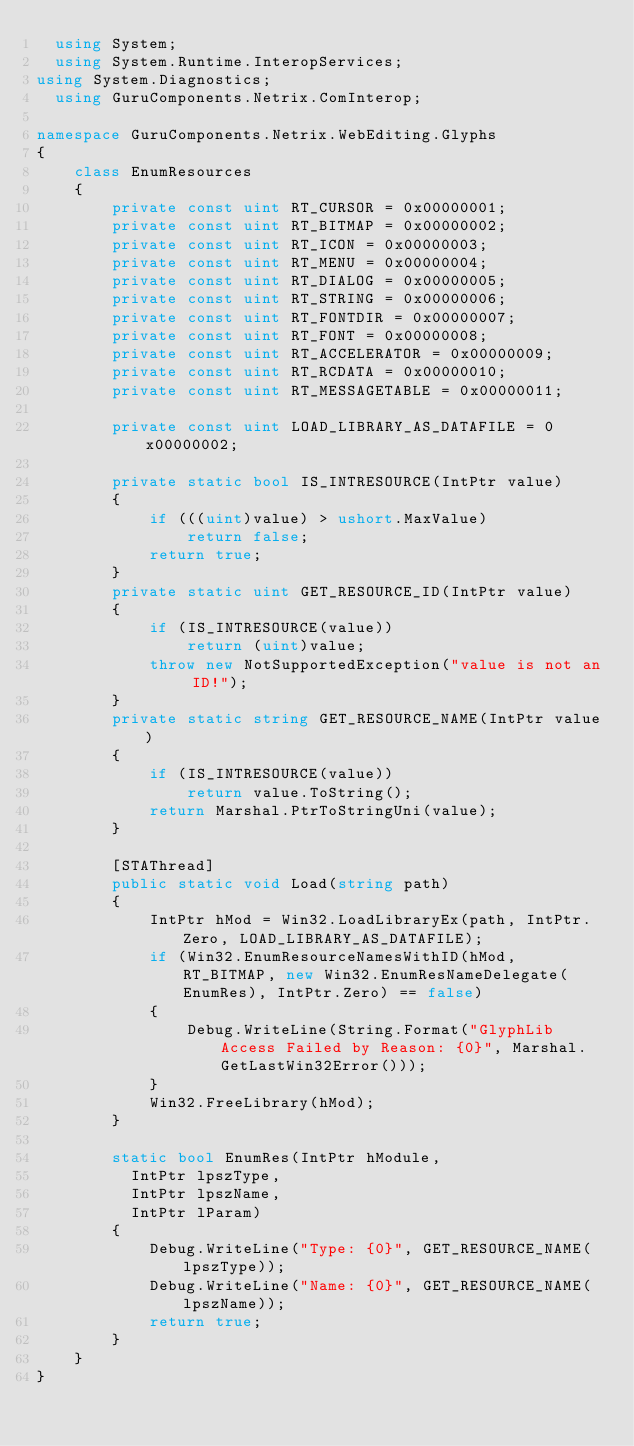Convert code to text. <code><loc_0><loc_0><loc_500><loc_500><_C#_>  using System;
  using System.Runtime.InteropServices;
using System.Diagnostics;
  using GuruComponents.Netrix.ComInterop;

namespace GuruComponents.Netrix.WebEditing.Glyphs
{
    class EnumResources
    {
        private const uint RT_CURSOR = 0x00000001;
        private const uint RT_BITMAP = 0x00000002;
        private const uint RT_ICON = 0x00000003;
        private const uint RT_MENU = 0x00000004;
        private const uint RT_DIALOG = 0x00000005;
        private const uint RT_STRING = 0x00000006;
        private const uint RT_FONTDIR = 0x00000007;
        private const uint RT_FONT = 0x00000008;
        private const uint RT_ACCELERATOR = 0x00000009;
        private const uint RT_RCDATA = 0x00000010;
        private const uint RT_MESSAGETABLE = 0x00000011;

        private const uint LOAD_LIBRARY_AS_DATAFILE = 0x00000002;

        private static bool IS_INTRESOURCE(IntPtr value)
        {
            if (((uint)value) > ushort.MaxValue)
                return false;
            return true;
        }
        private static uint GET_RESOURCE_ID(IntPtr value)
        {
            if (IS_INTRESOURCE(value))
                return (uint)value;
            throw new NotSupportedException("value is not an ID!");
        }
        private static string GET_RESOURCE_NAME(IntPtr value)
        {
            if (IS_INTRESOURCE(value))
                return value.ToString();
            return Marshal.PtrToStringUni(value);
        }

        [STAThread]
        public static void Load(string path)
        {
            IntPtr hMod = Win32.LoadLibraryEx(path, IntPtr.Zero, LOAD_LIBRARY_AS_DATAFILE);
            if (Win32.EnumResourceNamesWithID(hMod, RT_BITMAP, new Win32.EnumResNameDelegate(EnumRes), IntPtr.Zero) == false)
            {
                Debug.WriteLine(String.Format("GlyphLib Access Failed by Reason: {0}", Marshal.GetLastWin32Error()));
            }
            Win32.FreeLibrary(hMod);
        }

        static bool EnumRes(IntPtr hModule,
          IntPtr lpszType,
          IntPtr lpszName,
          IntPtr lParam)
        {
            Debug.WriteLine("Type: {0}", GET_RESOURCE_NAME(lpszType));
            Debug.WriteLine("Name: {0}", GET_RESOURCE_NAME(lpszName));
            return true;
        }
    }
}</code> 